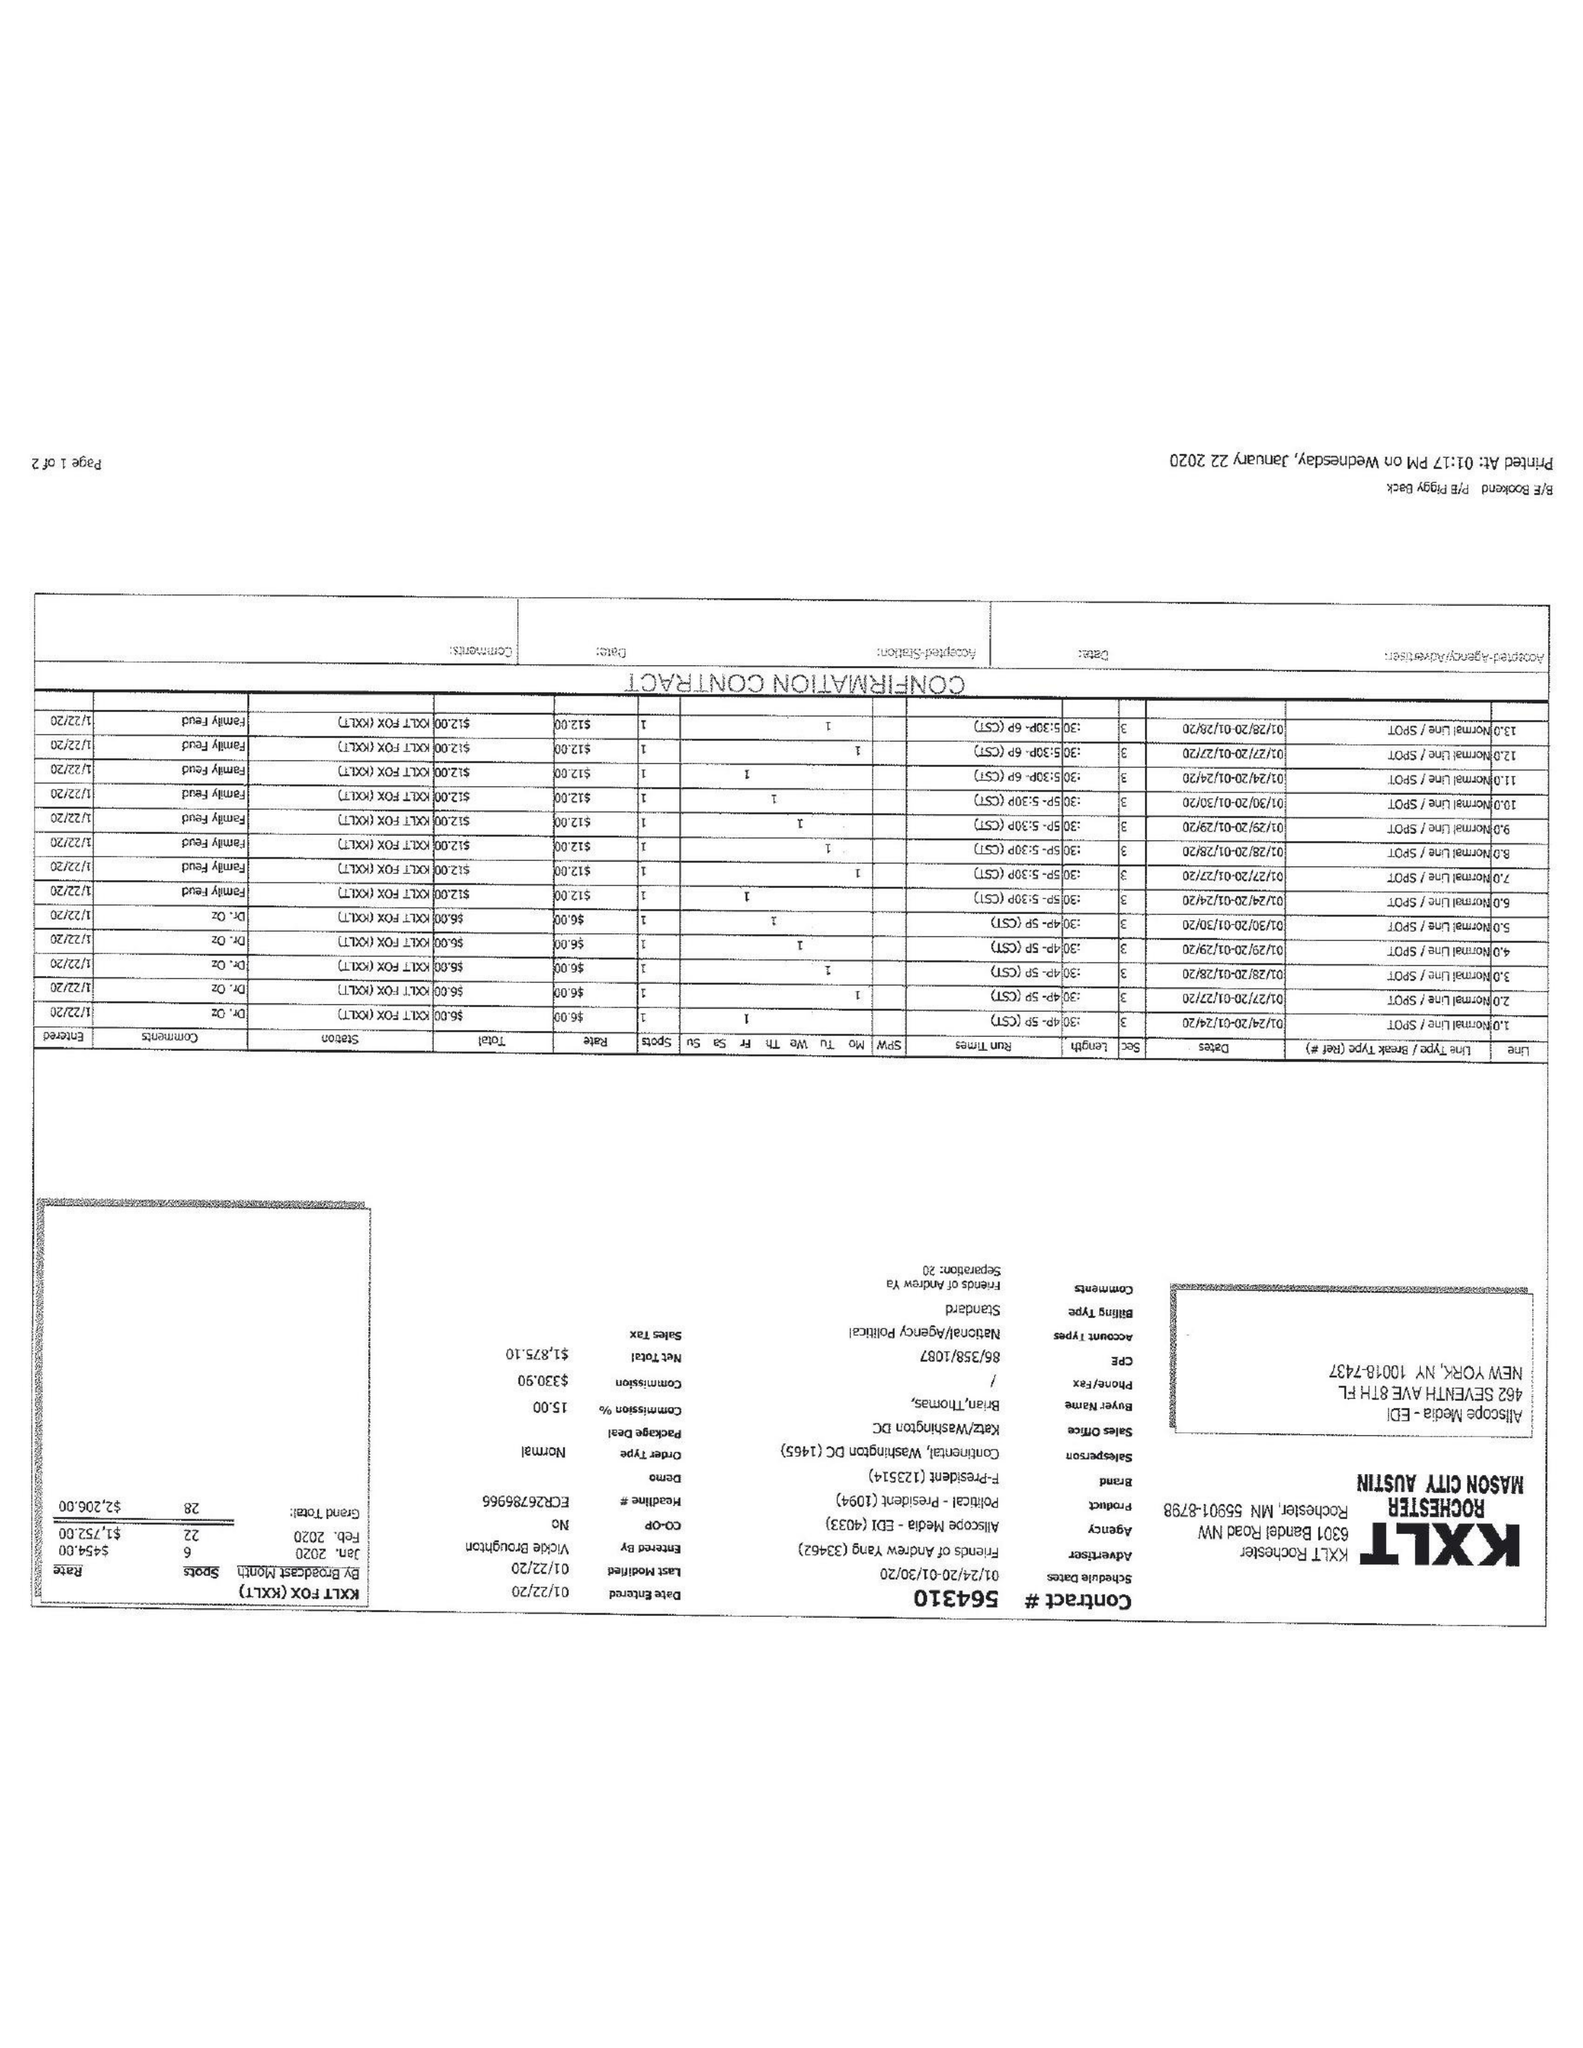What is the value for the contract_num?
Answer the question using a single word or phrase. 564310 